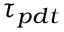<formula> <loc_0><loc_0><loc_500><loc_500>\tau _ { p d t }</formula> 